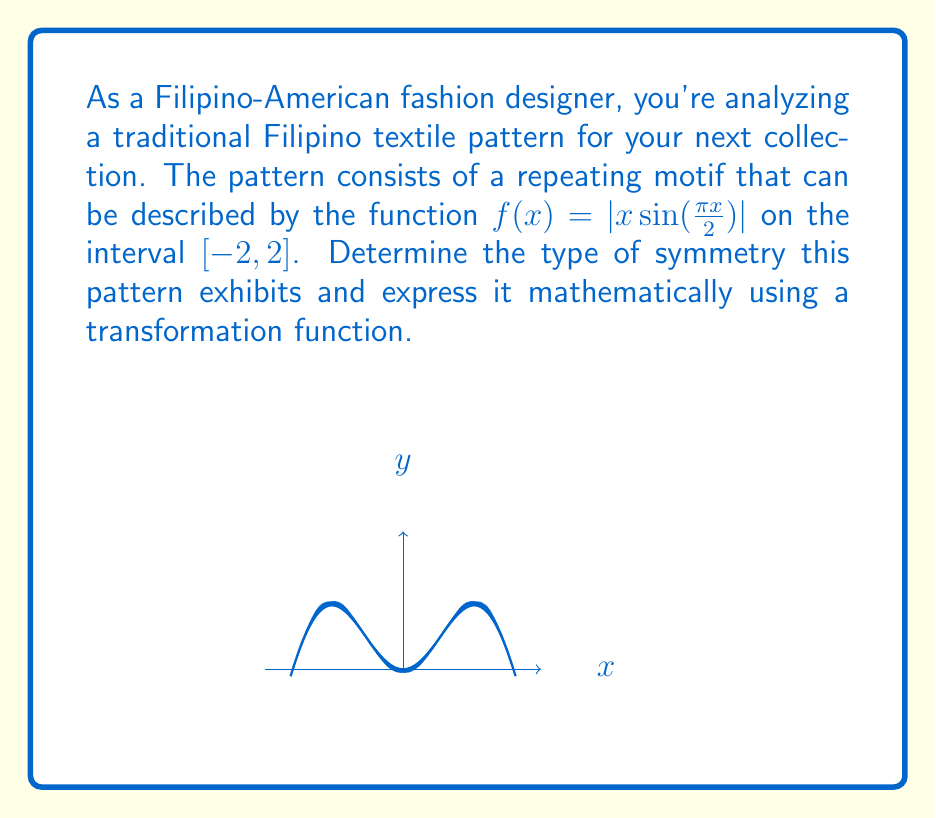Solve this math problem. Let's approach this step-by-step:

1) First, we need to understand what symmetry means in terms of functions. A function can have:
   - Even symmetry: $f(x) = f(-x)$
   - Odd symmetry: $f(x) = -f(-x)$
   - Origin symmetry: $f(x) = -f(-x)$ (same as odd symmetry)

2) Looking at the graph, we can see that it's symmetric about the y-axis. This suggests even symmetry.

3) To confirm, let's check if $f(x) = f(-x)$:

   $f(x) = |x \sin(\frac{\pi x}{2})|$
   $f(-x) = |(-x) \sin(\frac{\pi (-x)}{2})|$
          $= |-x \sin(-\frac{\pi x}{2})|$
          $= |x \sin(\frac{\pi x}{2})|$ (since $\sin(-\theta) = -\sin(\theta)$ and we're taking absolute value)

4) Indeed, $f(x) = f(-x)$, confirming even symmetry.

5) To express this mathematically using a transformation function, we can say that the pattern remains unchanged when reflected about the y-axis. This transformation can be represented as:

   $T(x, y) = (-x, y)$

6) In function notation, this symmetry can be expressed as:

   $f(x) = f(T_x(x))$, where $T_x(x) = -x$
Answer: Even symmetry; $f(x) = f(-x)$ 